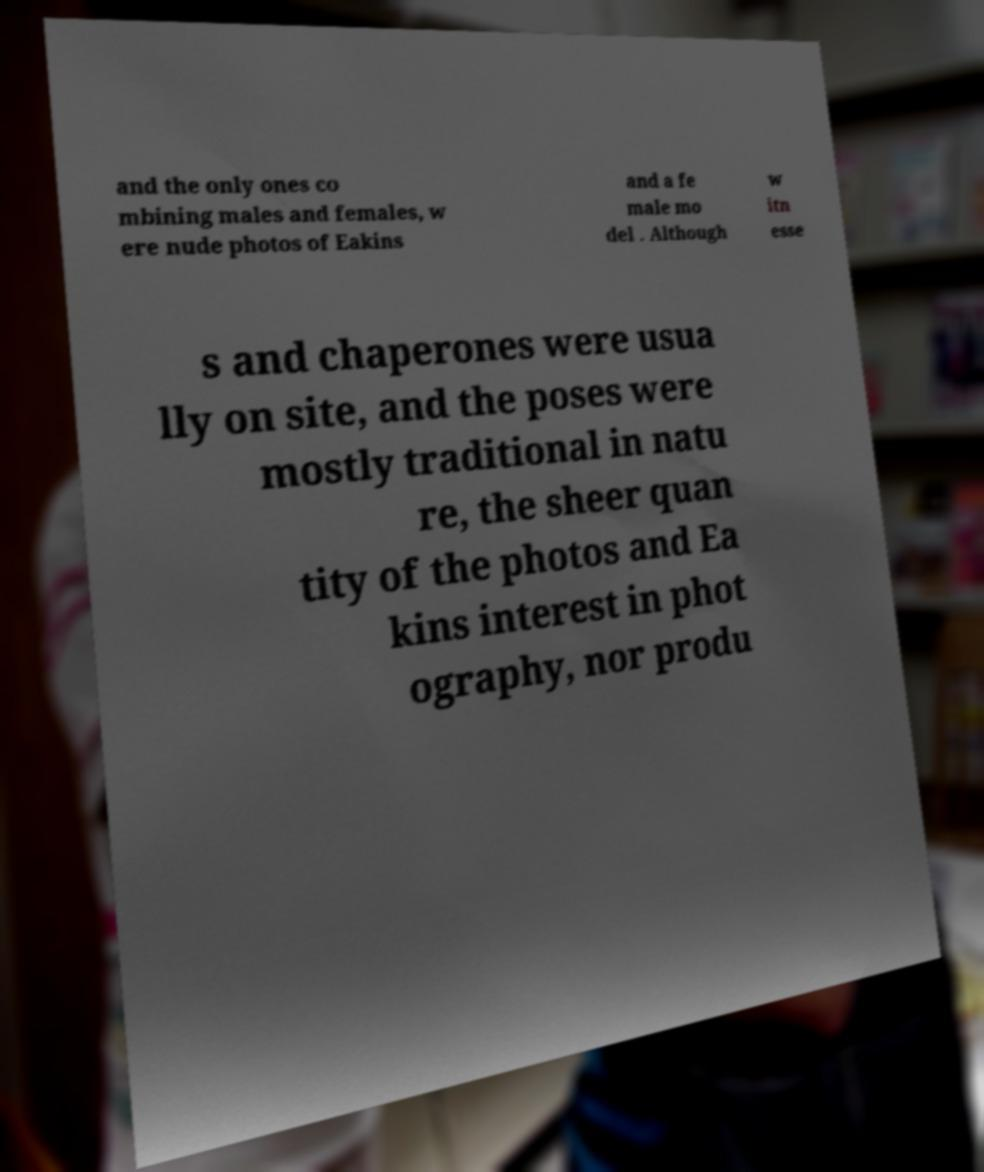Can you read and provide the text displayed in the image?This photo seems to have some interesting text. Can you extract and type it out for me? and the only ones co mbining males and females, w ere nude photos of Eakins and a fe male mo del . Although w itn esse s and chaperones were usua lly on site, and the poses were mostly traditional in natu re, the sheer quan tity of the photos and Ea kins interest in phot ography, nor produ 